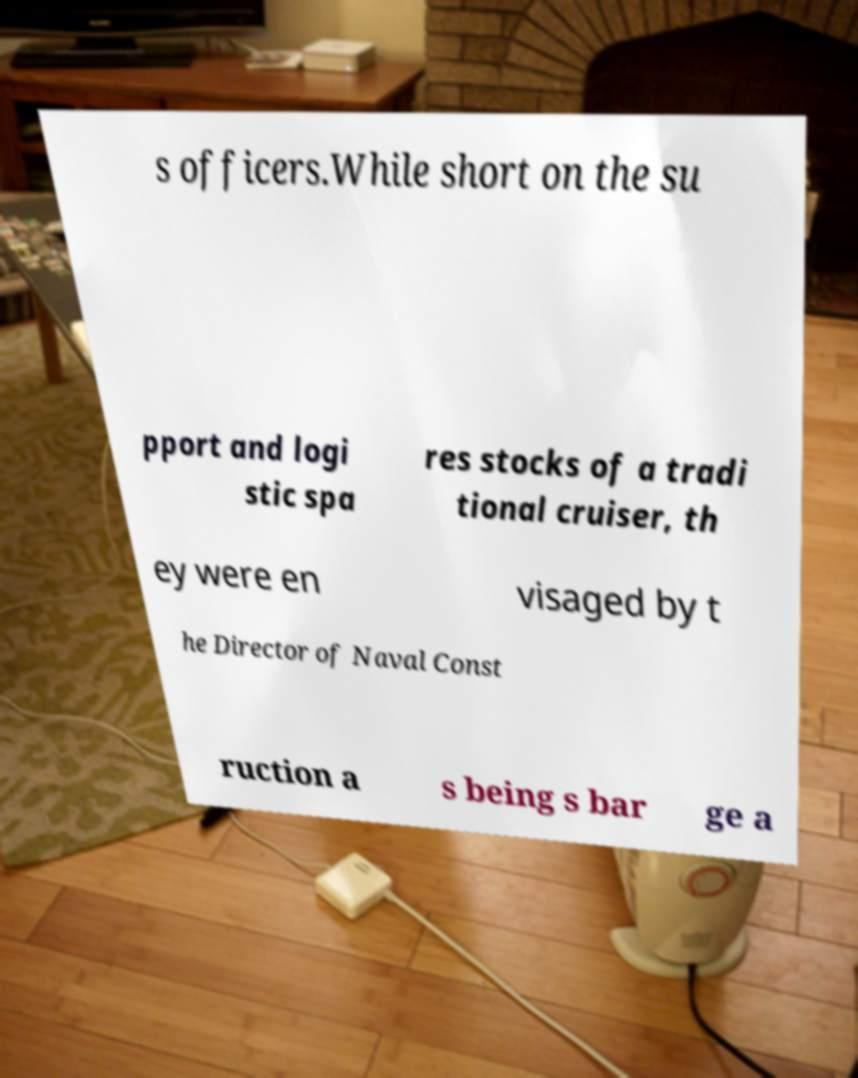Can you read and provide the text displayed in the image?This photo seems to have some interesting text. Can you extract and type it out for me? s officers.While short on the su pport and logi stic spa res stocks of a tradi tional cruiser, th ey were en visaged by t he Director of Naval Const ruction a s being s bar ge a 